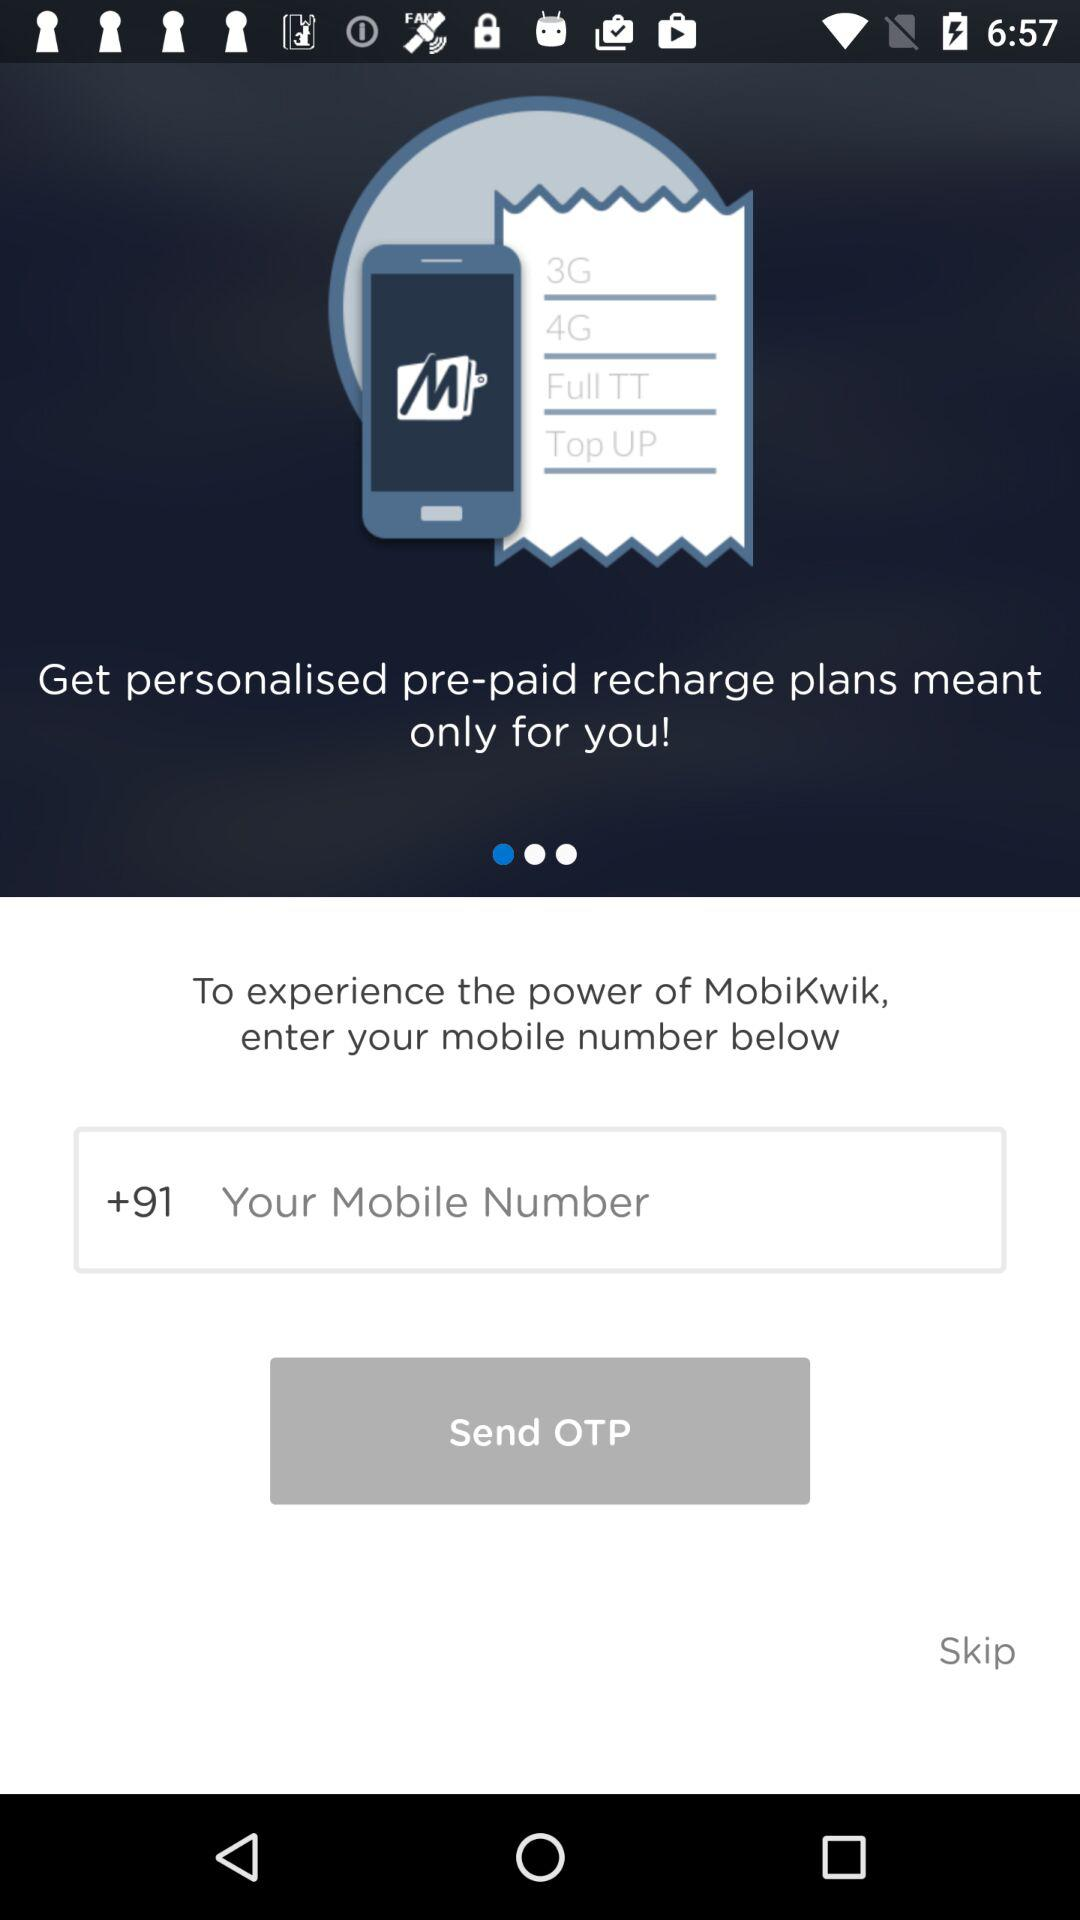What is the country code? The country code is +91. 